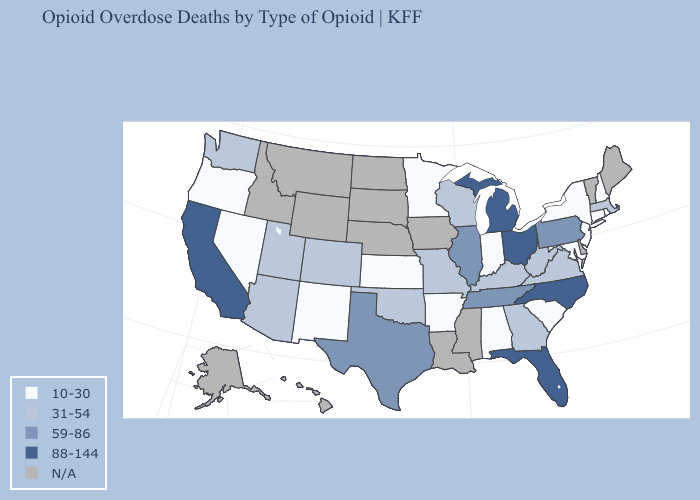Name the states that have a value in the range 10-30?
Keep it brief. Alabama, Arkansas, Connecticut, Indiana, Kansas, Maryland, Minnesota, Nevada, New Hampshire, New Jersey, New Mexico, New York, Oregon, Rhode Island, South Carolina. Name the states that have a value in the range 10-30?
Answer briefly. Alabama, Arkansas, Connecticut, Indiana, Kansas, Maryland, Minnesota, Nevada, New Hampshire, New Jersey, New Mexico, New York, Oregon, Rhode Island, South Carolina. How many symbols are there in the legend?
Short answer required. 5. What is the highest value in the South ?
Answer briefly. 88-144. What is the value of Texas?
Keep it brief. 59-86. Name the states that have a value in the range 31-54?
Concise answer only. Arizona, Colorado, Georgia, Kentucky, Massachusetts, Missouri, Oklahoma, Utah, Virginia, Washington, West Virginia, Wisconsin. Which states have the highest value in the USA?
Give a very brief answer. California, Florida, Michigan, North Carolina, Ohio. Name the states that have a value in the range N/A?
Short answer required. Alaska, Delaware, Hawaii, Idaho, Iowa, Louisiana, Maine, Mississippi, Montana, Nebraska, North Dakota, South Dakota, Vermont, Wyoming. Does Rhode Island have the lowest value in the USA?
Keep it brief. Yes. Among the states that border North Carolina , does Tennessee have the highest value?
Short answer required. Yes. Which states hav the highest value in the Northeast?
Short answer required. Pennsylvania. Name the states that have a value in the range 88-144?
Be succinct. California, Florida, Michigan, North Carolina, Ohio. 